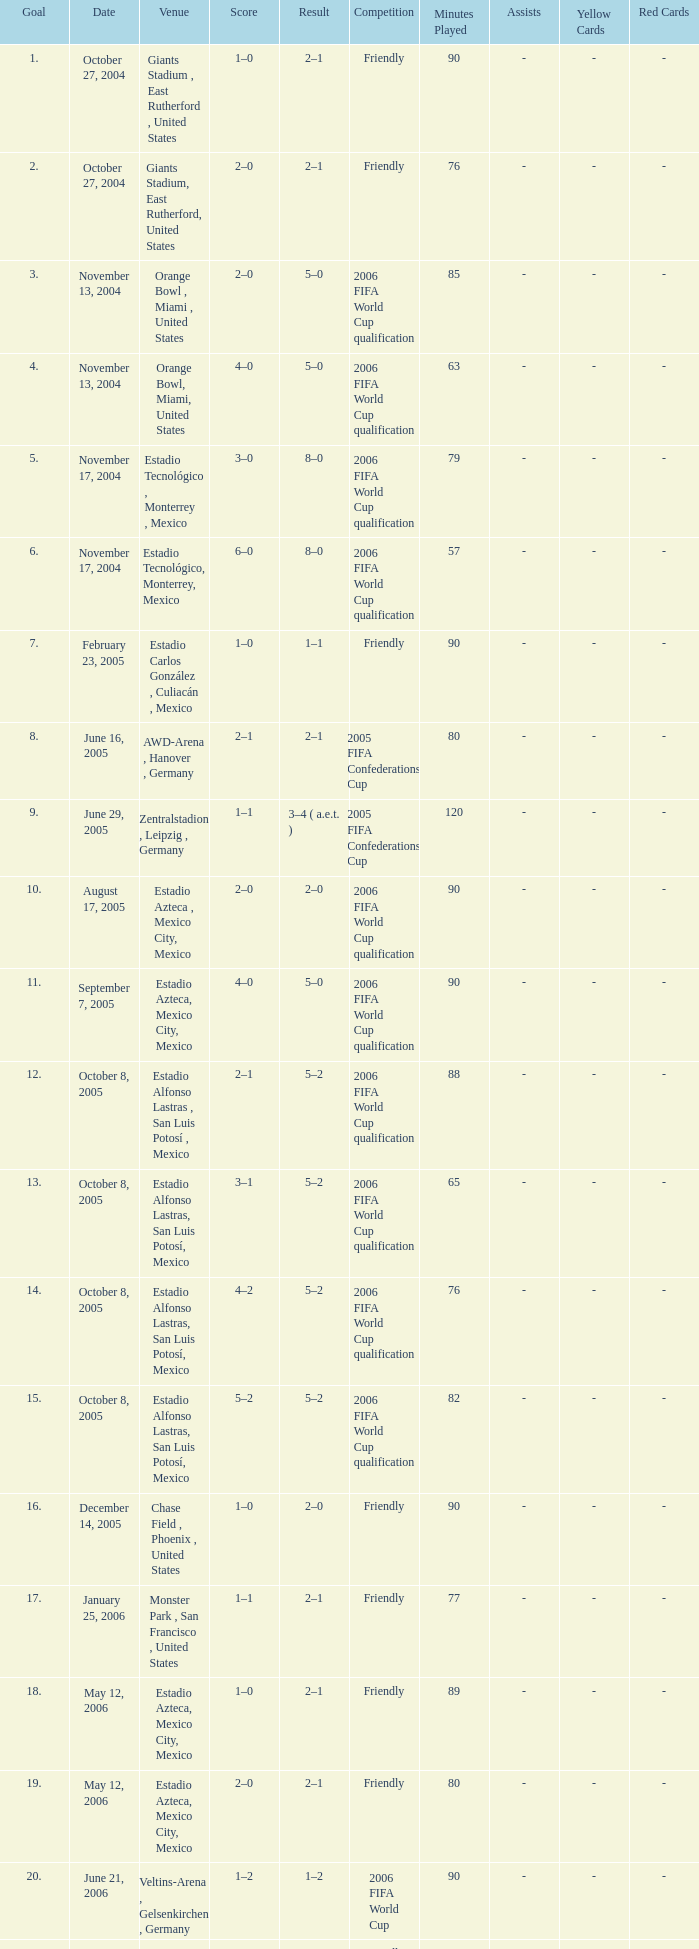Which Result has a Score of 1–0, and a Goal of 16? 2–0. 